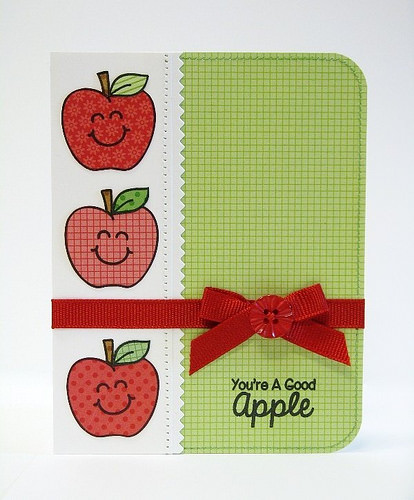<image>
Is the apple above the card? No. The apple is not positioned above the card. The vertical arrangement shows a different relationship. 